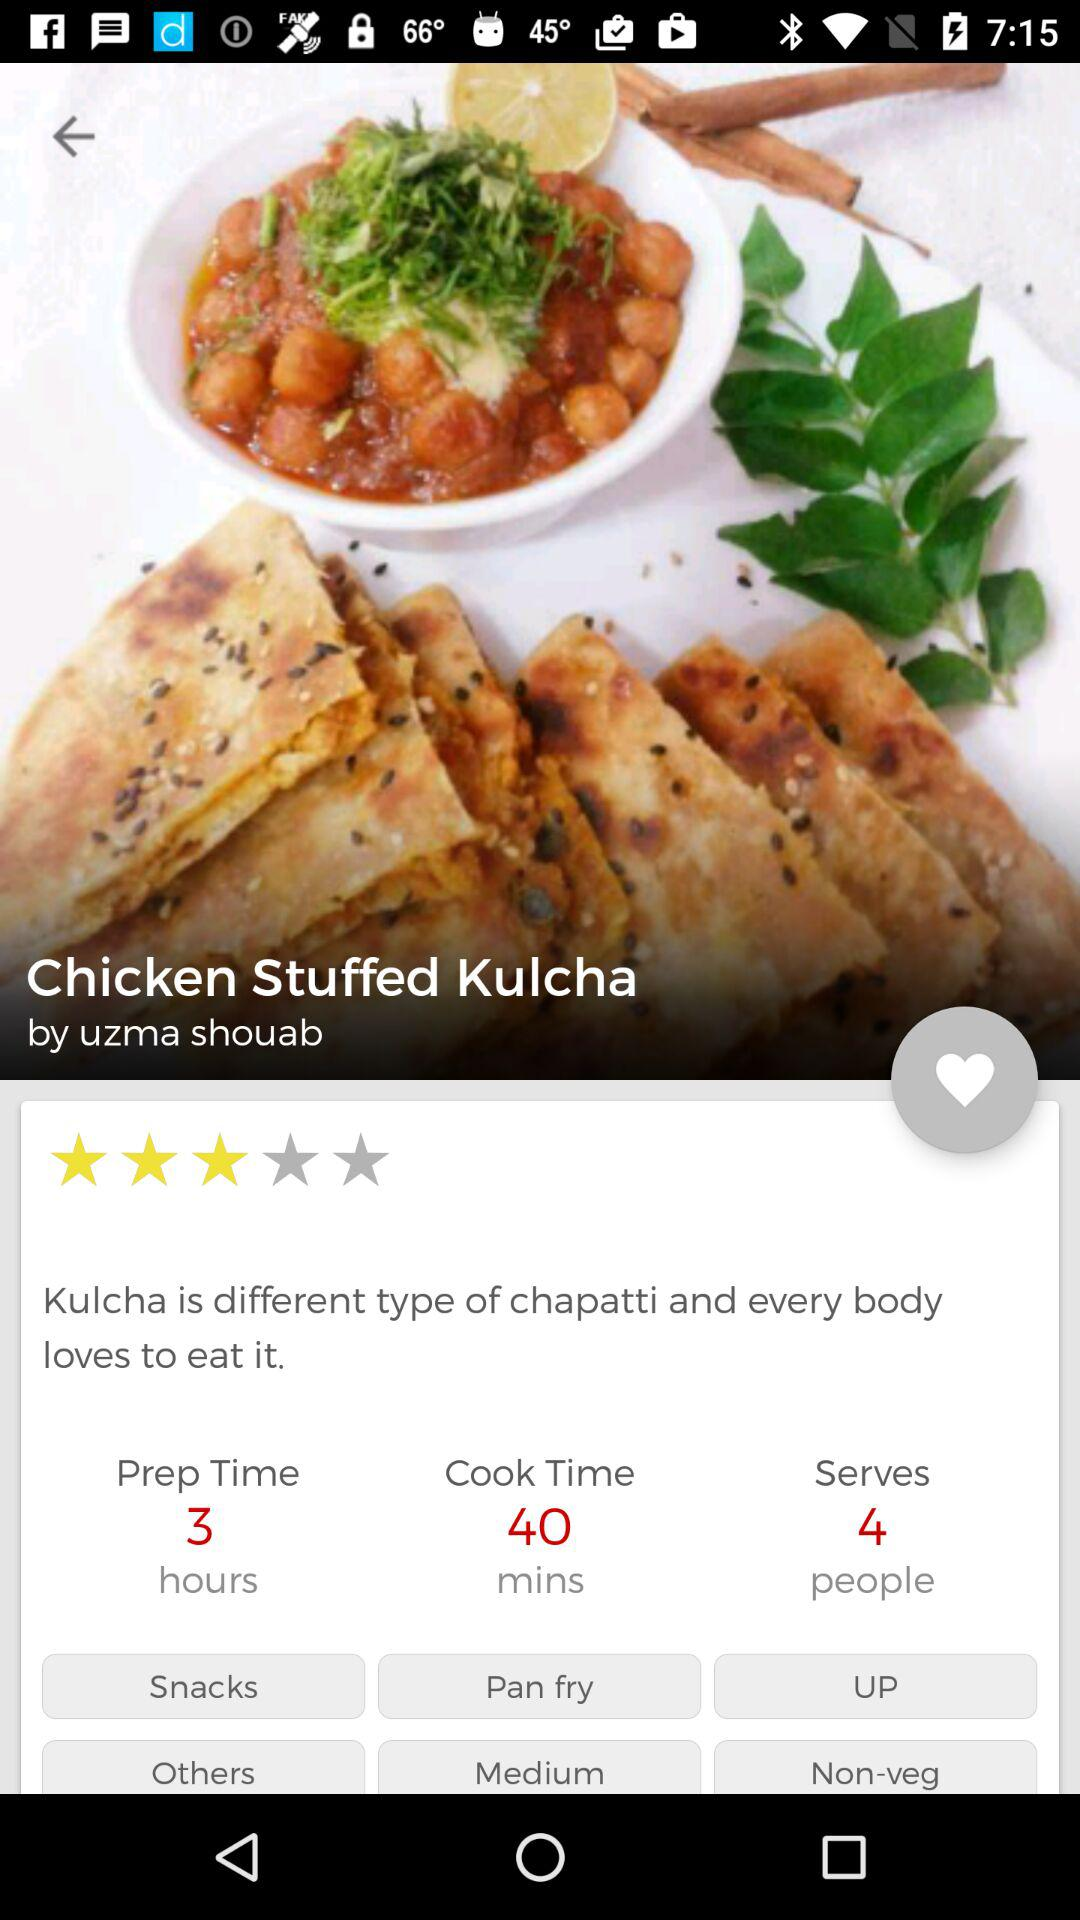How many people can the dish be served to? The dish can be served to 4 people. 